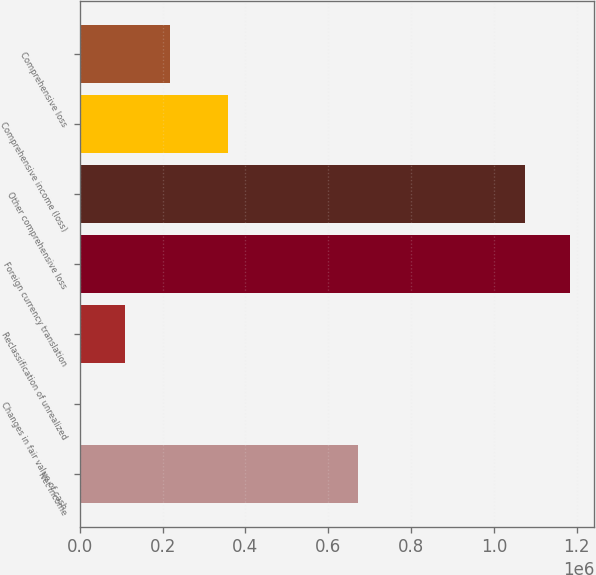<chart> <loc_0><loc_0><loc_500><loc_500><bar_chart><fcel>Net income<fcel>Changes in fair value of cash<fcel>Reclassification of unrealized<fcel>Foreign currency translation<fcel>Other comprehensive loss<fcel>Comprehensive income (loss)<fcel>Comprehensive loss<nl><fcel>672007<fcel>948<fcel>108748<fcel>1.18336e+06<fcel>1.07556e+06<fcel>357701<fcel>216548<nl></chart> 